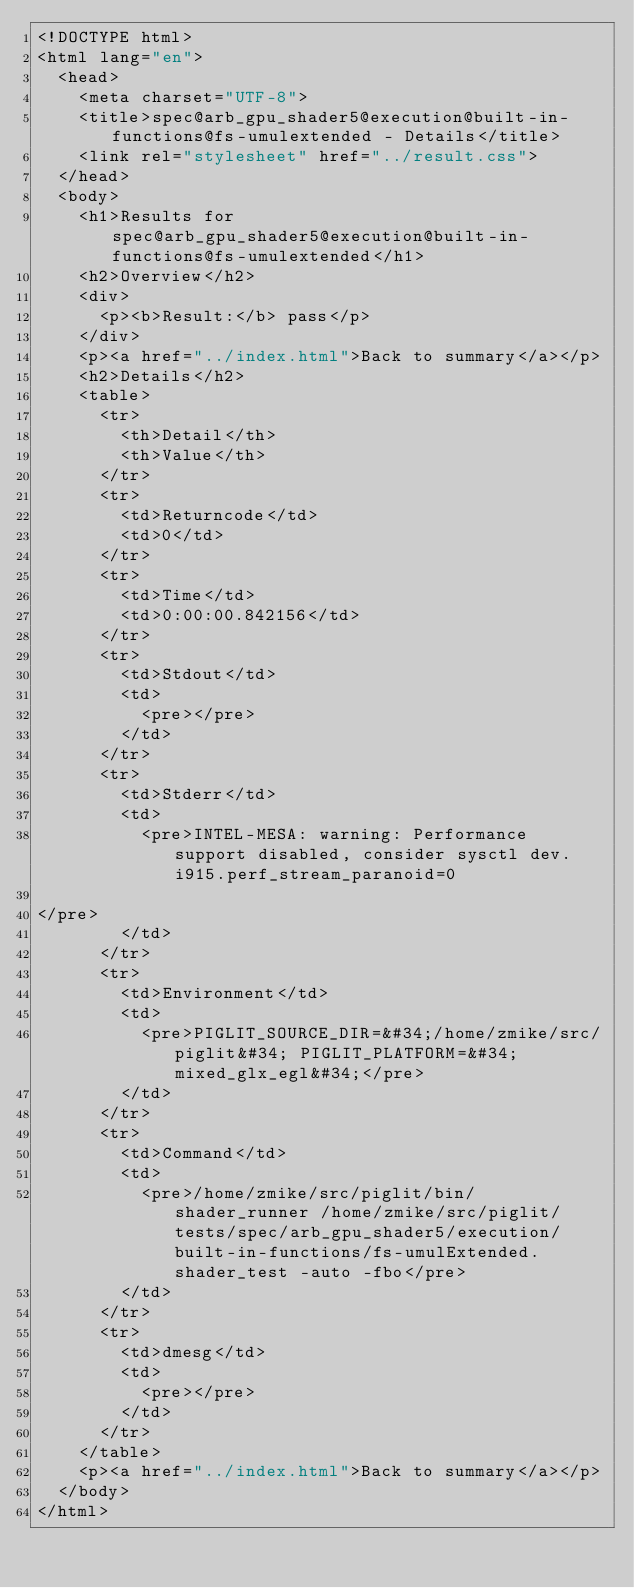Convert code to text. <code><loc_0><loc_0><loc_500><loc_500><_HTML_><!DOCTYPE html>
<html lang="en">
  <head>
    <meta charset="UTF-8">
    <title>spec@arb_gpu_shader5@execution@built-in-functions@fs-umulextended - Details</title>
    <link rel="stylesheet" href="../result.css">
  </head>
  <body>
    <h1>Results for spec@arb_gpu_shader5@execution@built-in-functions@fs-umulextended</h1>
    <h2>Overview</h2>
    <div>
      <p><b>Result:</b> pass</p>
    </div>
    <p><a href="../index.html">Back to summary</a></p>
    <h2>Details</h2>
    <table>
      <tr>
        <th>Detail</th>
        <th>Value</th>
      </tr>
      <tr>
        <td>Returncode</td>
        <td>0</td>
      </tr>
      <tr>
        <td>Time</td>
        <td>0:00:00.842156</td>
      </tr>
      <tr>
        <td>Stdout</td>
        <td>
          <pre></pre>
        </td>
      </tr>
      <tr>
        <td>Stderr</td>
        <td>
          <pre>INTEL-MESA: warning: Performance support disabled, consider sysctl dev.i915.perf_stream_paranoid=0

</pre>
        </td>
      </tr>
      <tr>
        <td>Environment</td>
        <td>
          <pre>PIGLIT_SOURCE_DIR=&#34;/home/zmike/src/piglit&#34; PIGLIT_PLATFORM=&#34;mixed_glx_egl&#34;</pre>
        </td>
      </tr>
      <tr>
        <td>Command</td>
        <td>
          <pre>/home/zmike/src/piglit/bin/shader_runner /home/zmike/src/piglit/tests/spec/arb_gpu_shader5/execution/built-in-functions/fs-umulExtended.shader_test -auto -fbo</pre>
        </td>
      </tr>
      <tr>
        <td>dmesg</td>
        <td>
          <pre></pre>
        </td>
      </tr>
    </table>
    <p><a href="../index.html">Back to summary</a></p>
  </body>
</html>
</code> 